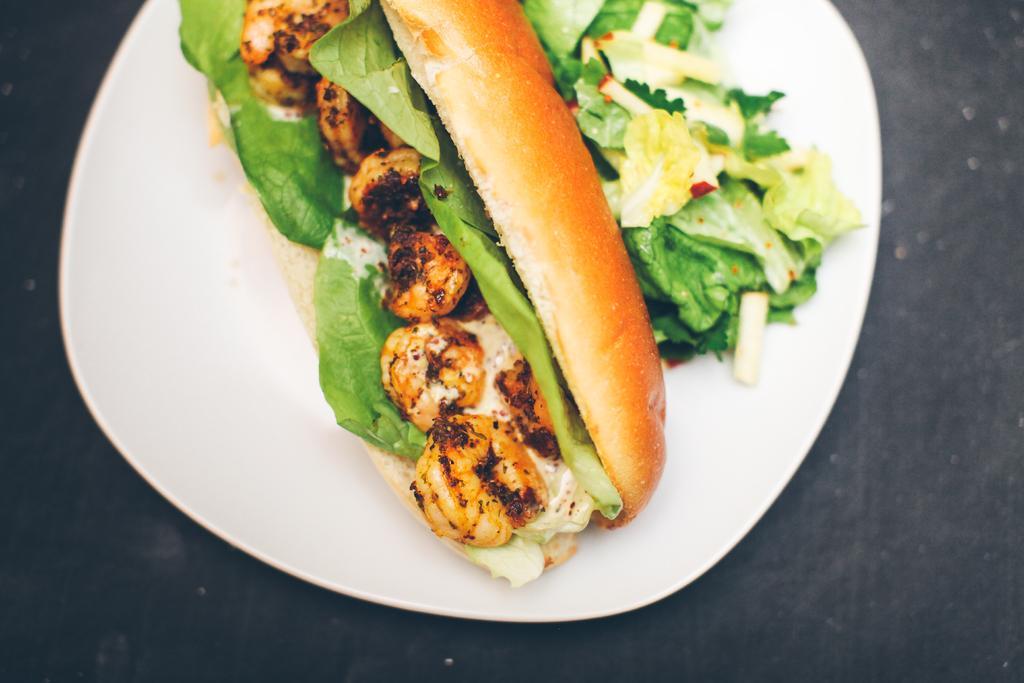Could you give a brief overview of what you see in this image? In this picture we can see a hot dog kept on a white plate. 